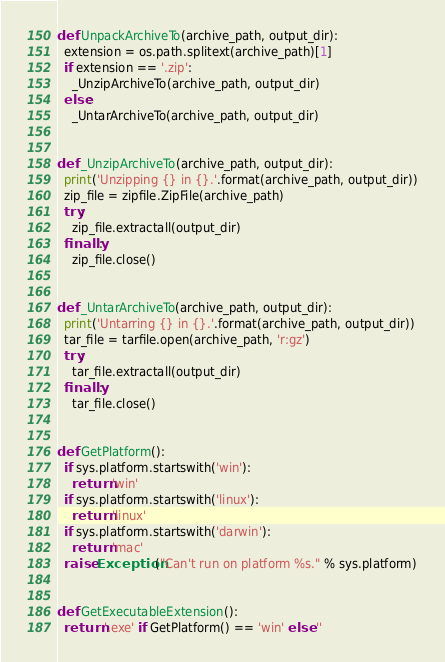Convert code to text. <code><loc_0><loc_0><loc_500><loc_500><_Python_>
def UnpackArchiveTo(archive_path, output_dir):
  extension = os.path.splitext(archive_path)[1]
  if extension == '.zip':
    _UnzipArchiveTo(archive_path, output_dir)
  else:
    _UntarArchiveTo(archive_path, output_dir)


def _UnzipArchiveTo(archive_path, output_dir):
  print('Unzipping {} in {}.'.format(archive_path, output_dir))
  zip_file = zipfile.ZipFile(archive_path)
  try:
    zip_file.extractall(output_dir)
  finally:
    zip_file.close()


def _UntarArchiveTo(archive_path, output_dir):
  print('Untarring {} in {}.'.format(archive_path, output_dir))
  tar_file = tarfile.open(archive_path, 'r:gz')
  try:
    tar_file.extractall(output_dir)
  finally:
    tar_file.close()


def GetPlatform():
  if sys.platform.startswith('win'):
    return 'win'
  if sys.platform.startswith('linux'):
    return 'linux'
  if sys.platform.startswith('darwin'):
    return 'mac'
  raise Exception("Can't run on platform %s." % sys.platform)


def GetExecutableExtension():
  return '.exe' if GetPlatform() == 'win' else ''
</code> 